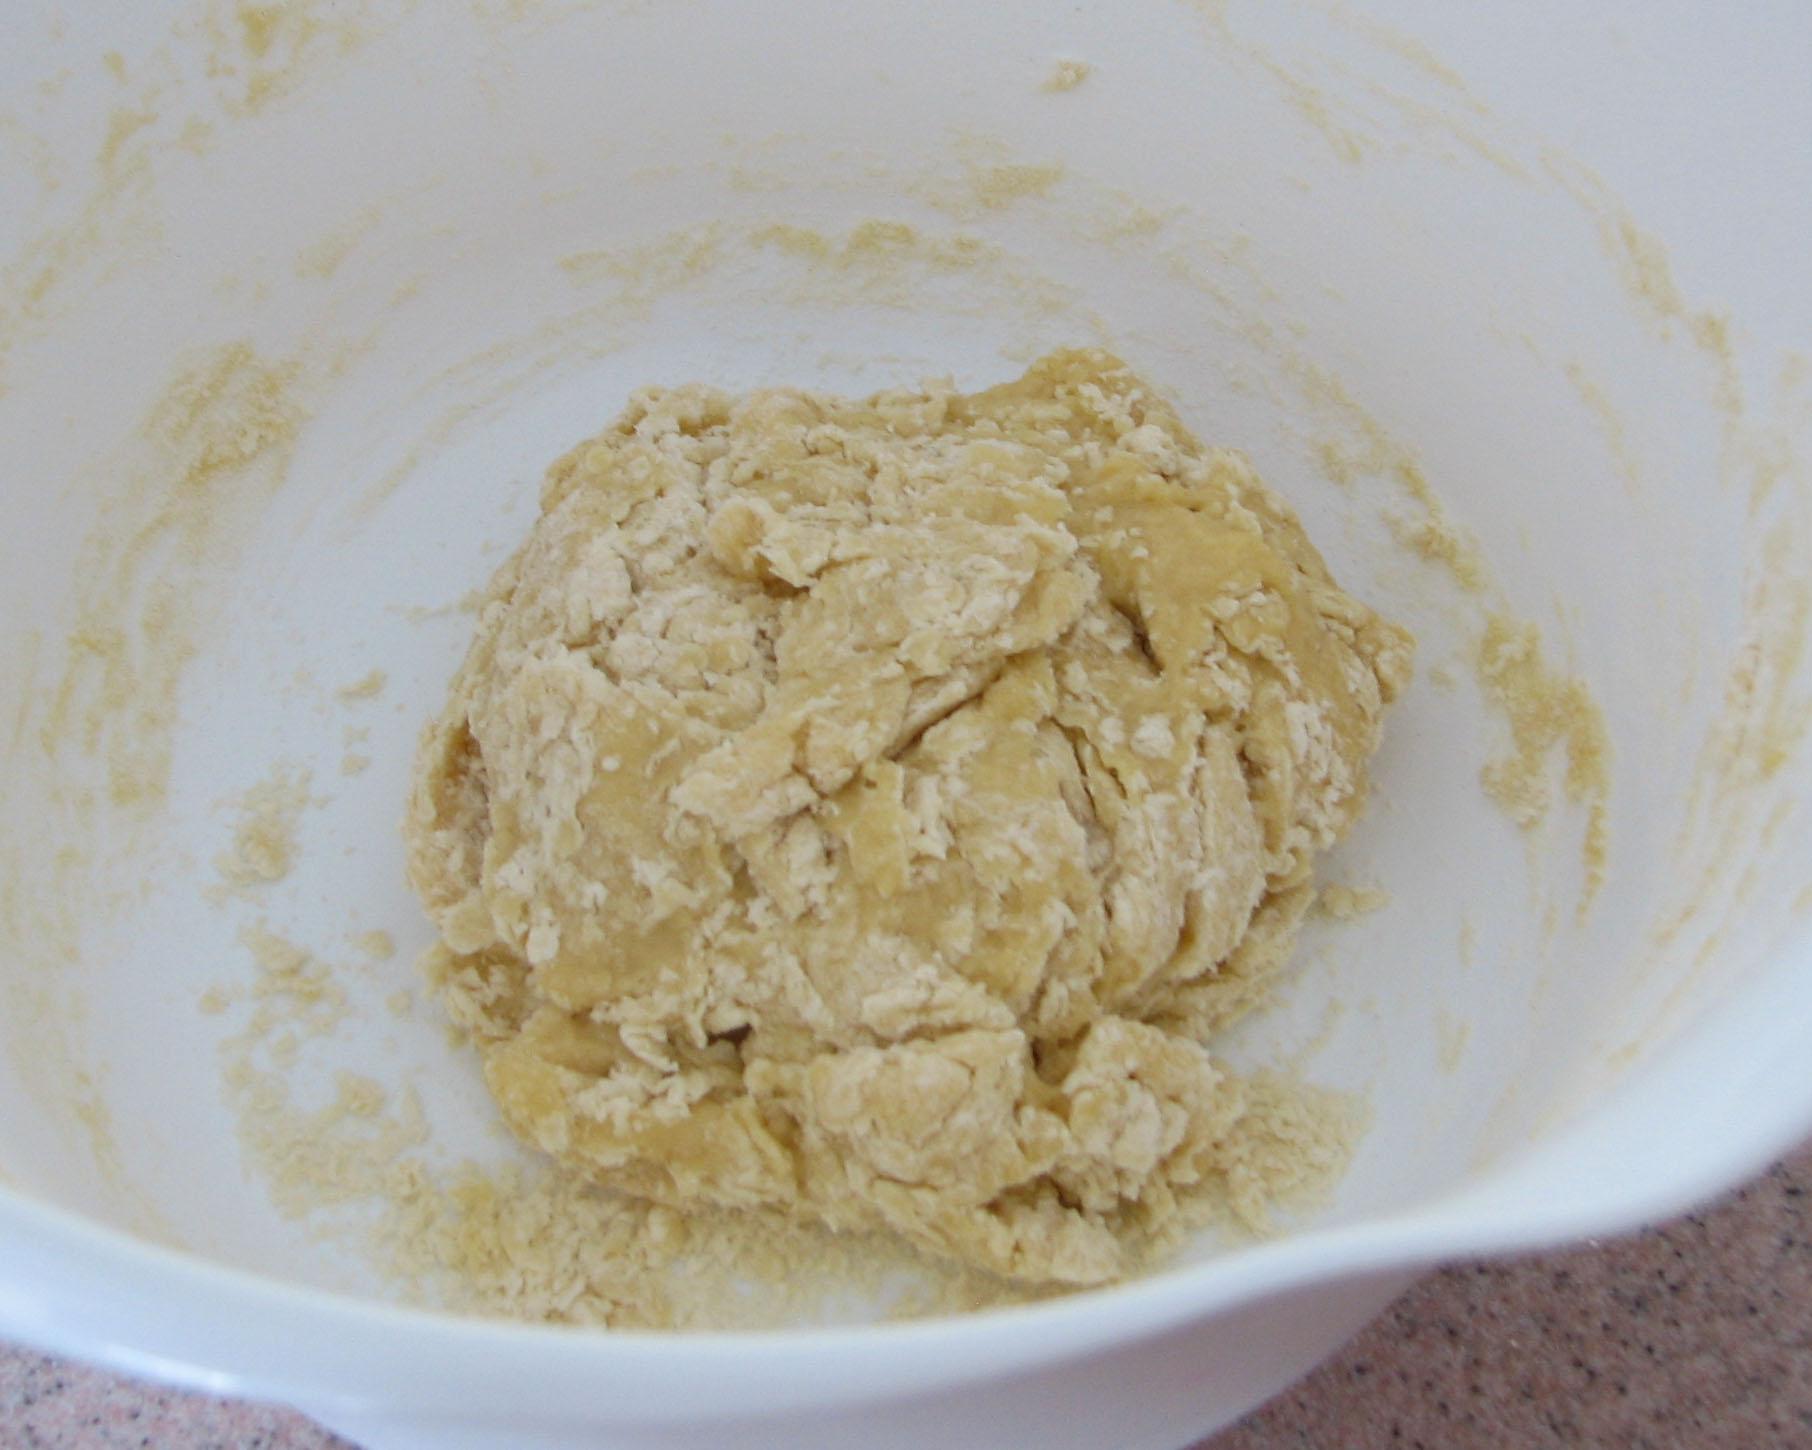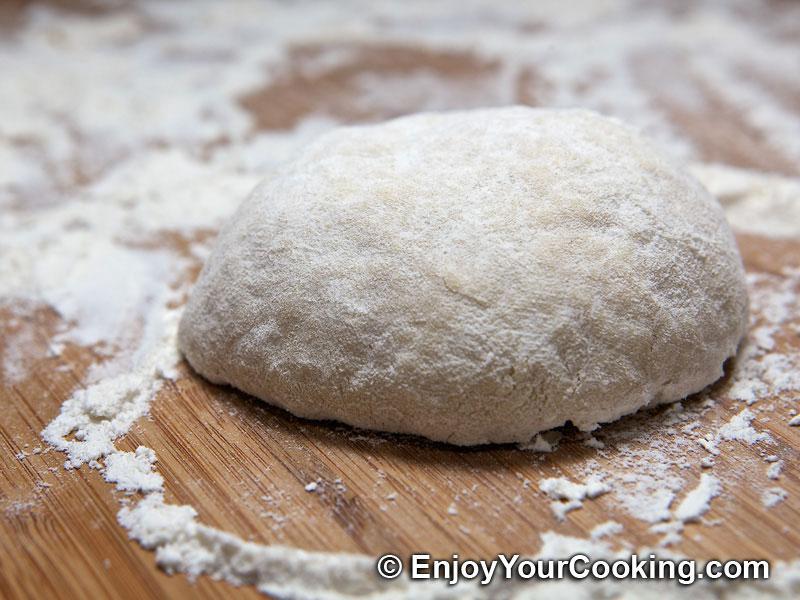The first image is the image on the left, the second image is the image on the right. Examine the images to the left and right. Is the description "An image contains a human hand touching a mound of dough." accurate? Answer yes or no. No. The first image is the image on the left, the second image is the image on the right. Analyze the images presented: Is the assertion "Dough and flour are on a wooden cutting board." valid? Answer yes or no. Yes. 